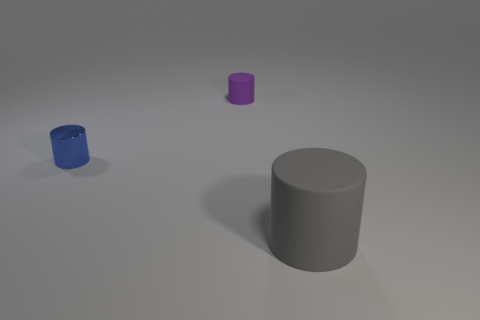Add 1 purple matte cylinders. How many objects exist? 4 Add 2 large gray rubber things. How many large gray rubber things exist? 3 Subtract 0 blue blocks. How many objects are left? 3 Subtract all large yellow shiny cubes. Subtract all tiny rubber things. How many objects are left? 2 Add 3 big gray rubber objects. How many big gray rubber objects are left? 4 